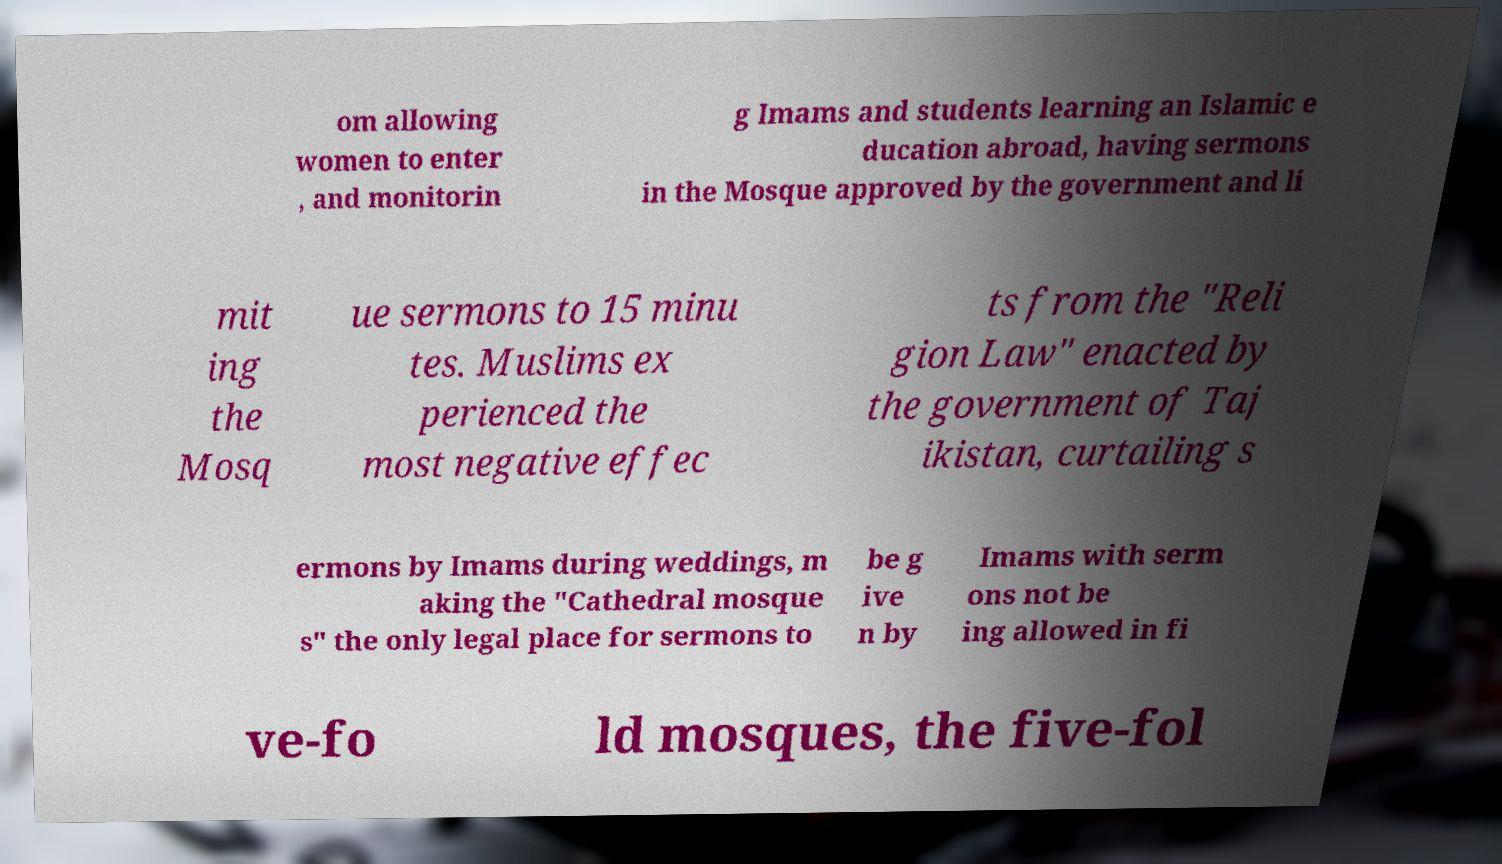Please identify and transcribe the text found in this image. om allowing women to enter , and monitorin g Imams and students learning an Islamic e ducation abroad, having sermons in the Mosque approved by the government and li mit ing the Mosq ue sermons to 15 minu tes. Muslims ex perienced the most negative effec ts from the "Reli gion Law" enacted by the government of Taj ikistan, curtailing s ermons by Imams during weddings, m aking the "Cathedral mosque s" the only legal place for sermons to be g ive n by Imams with serm ons not be ing allowed in fi ve-fo ld mosques, the five-fol 